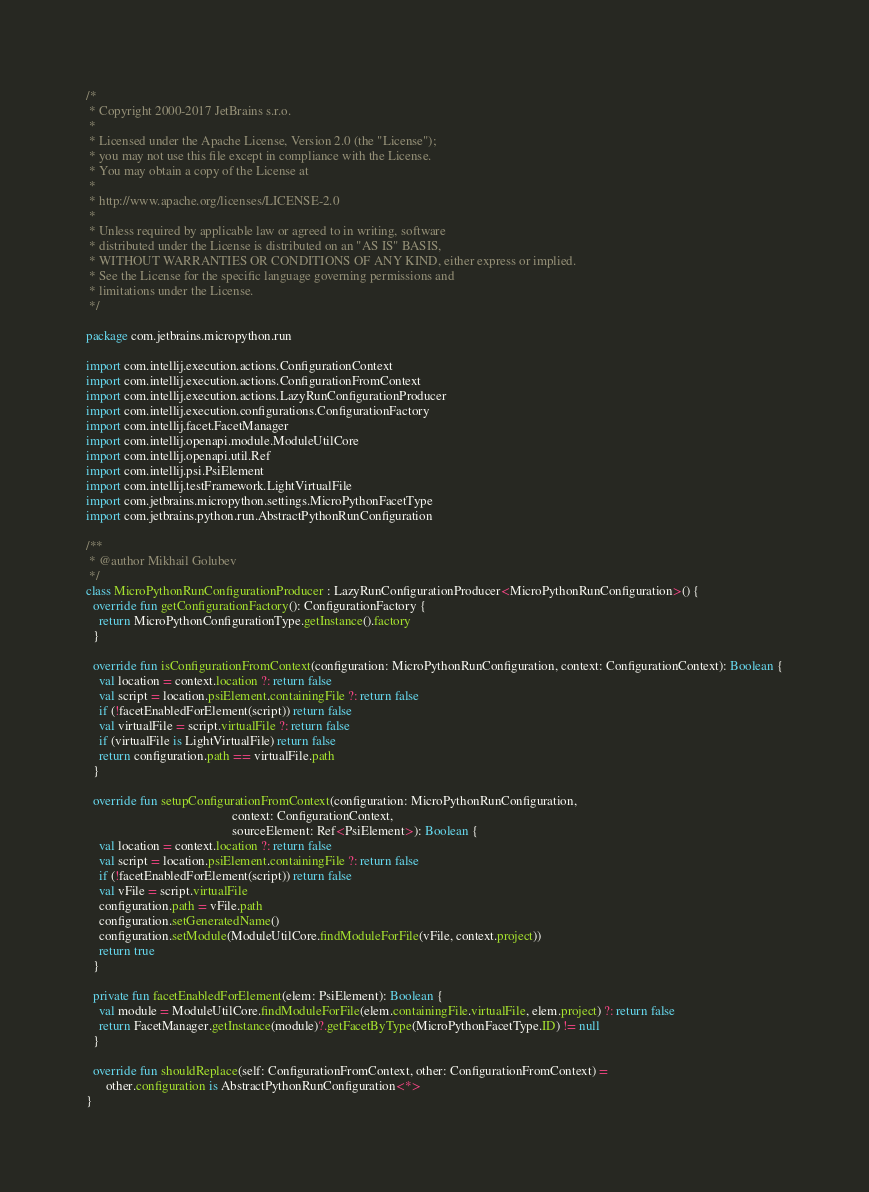Convert code to text. <code><loc_0><loc_0><loc_500><loc_500><_Kotlin_>/*
 * Copyright 2000-2017 JetBrains s.r.o.
 *
 * Licensed under the Apache License, Version 2.0 (the "License");
 * you may not use this file except in compliance with the License.
 * You may obtain a copy of the License at
 *
 * http://www.apache.org/licenses/LICENSE-2.0
 *
 * Unless required by applicable law or agreed to in writing, software
 * distributed under the License is distributed on an "AS IS" BASIS,
 * WITHOUT WARRANTIES OR CONDITIONS OF ANY KIND, either express or implied.
 * See the License for the specific language governing permissions and
 * limitations under the License.
 */

package com.jetbrains.micropython.run

import com.intellij.execution.actions.ConfigurationContext
import com.intellij.execution.actions.ConfigurationFromContext
import com.intellij.execution.actions.LazyRunConfigurationProducer
import com.intellij.execution.configurations.ConfigurationFactory
import com.intellij.facet.FacetManager
import com.intellij.openapi.module.ModuleUtilCore
import com.intellij.openapi.util.Ref
import com.intellij.psi.PsiElement
import com.intellij.testFramework.LightVirtualFile
import com.jetbrains.micropython.settings.MicroPythonFacetType
import com.jetbrains.python.run.AbstractPythonRunConfiguration

/**
 * @author Mikhail Golubev
 */
class MicroPythonRunConfigurationProducer : LazyRunConfigurationProducer<MicroPythonRunConfiguration>() {
  override fun getConfigurationFactory(): ConfigurationFactory {
    return MicroPythonConfigurationType.getInstance().factory
  }

  override fun isConfigurationFromContext(configuration: MicroPythonRunConfiguration, context: ConfigurationContext): Boolean {
    val location = context.location ?: return false
    val script = location.psiElement.containingFile ?: return false
    if (!facetEnabledForElement(script)) return false
    val virtualFile = script.virtualFile ?: return false
    if (virtualFile is LightVirtualFile) return false
    return configuration.path == virtualFile.path
  }

  override fun setupConfigurationFromContext(configuration: MicroPythonRunConfiguration,
                                             context: ConfigurationContext,
                                             sourceElement: Ref<PsiElement>): Boolean {
    val location = context.location ?: return false
    val script = location.psiElement.containingFile ?: return false
    if (!facetEnabledForElement(script)) return false
    val vFile = script.virtualFile
    configuration.path = vFile.path
    configuration.setGeneratedName()
    configuration.setModule(ModuleUtilCore.findModuleForFile(vFile, context.project))
    return true
  }

  private fun facetEnabledForElement(elem: PsiElement): Boolean {
    val module = ModuleUtilCore.findModuleForFile(elem.containingFile.virtualFile, elem.project) ?: return false
    return FacetManager.getInstance(module)?.getFacetByType(MicroPythonFacetType.ID) != null
  }

  override fun shouldReplace(self: ConfigurationFromContext, other: ConfigurationFromContext) =
      other.configuration is AbstractPythonRunConfiguration<*>
}
</code> 